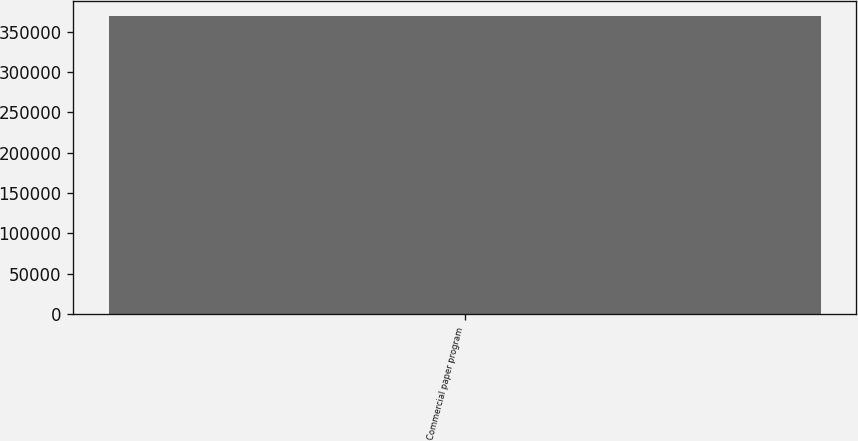Convert chart to OTSL. <chart><loc_0><loc_0><loc_500><loc_500><bar_chart><fcel>Commercial paper program<nl><fcel>369500<nl></chart> 